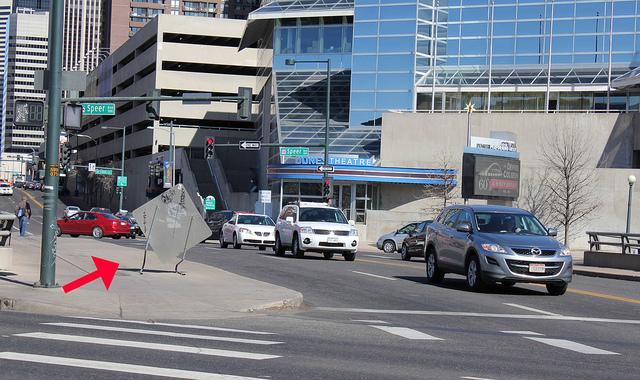What boulevard is the Jones Theater on? Please explain your reasoning. speer. The street sign has the name of the street that this theater is on. 